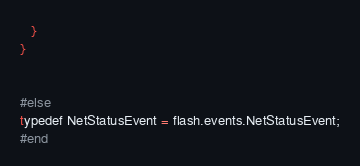<code> <loc_0><loc_0><loc_500><loc_500><_Haxe_>   }
}


#else
typedef NetStatusEvent = flash.events.NetStatusEvent;
#end


</code> 